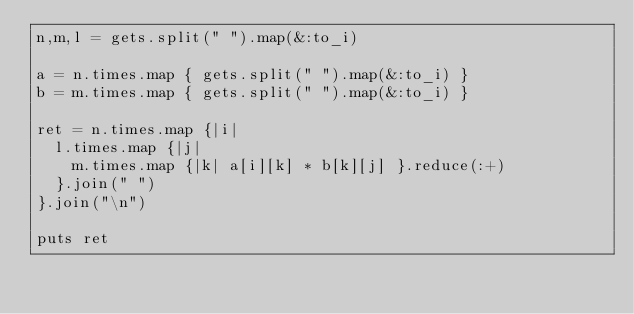Convert code to text. <code><loc_0><loc_0><loc_500><loc_500><_Ruby_>n,m,l = gets.split(" ").map(&:to_i)

a = n.times.map { gets.split(" ").map(&:to_i) }
b = m.times.map { gets.split(" ").map(&:to_i) }

ret = n.times.map {|i|
  l.times.map {|j|
    m.times.map {|k| a[i][k] * b[k][j] }.reduce(:+)
  }.join(" ")
}.join("\n")

puts ret</code> 